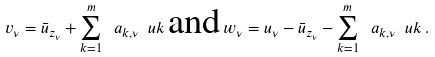Convert formula to latex. <formula><loc_0><loc_0><loc_500><loc_500>v _ { \nu } = \bar { u } _ { z _ { \nu } } + \sum _ { k = 1 } ^ { m } \ a _ { k , \nu } \ u k \, \text {and} \, w _ { \nu } = u _ { \nu } - \bar { u } _ { z _ { \nu } } - \sum _ { k = 1 } ^ { m } \ a _ { k , \nu } \ u k \, .</formula> 